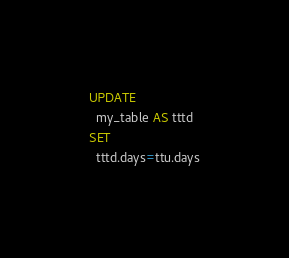Convert code to text. <code><loc_0><loc_0><loc_500><loc_500><_SQL_>UPDATE
  my_table AS tttd
SET
  tttd.days=ttu.days
</code> 